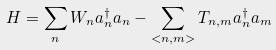<formula> <loc_0><loc_0><loc_500><loc_500>H = \sum _ { n } W _ { n } a _ { n } ^ { \dagger } a _ { n } - \sum _ { < n , m > } T _ { n , m } a _ { n } ^ { \dagger } a _ { m }</formula> 